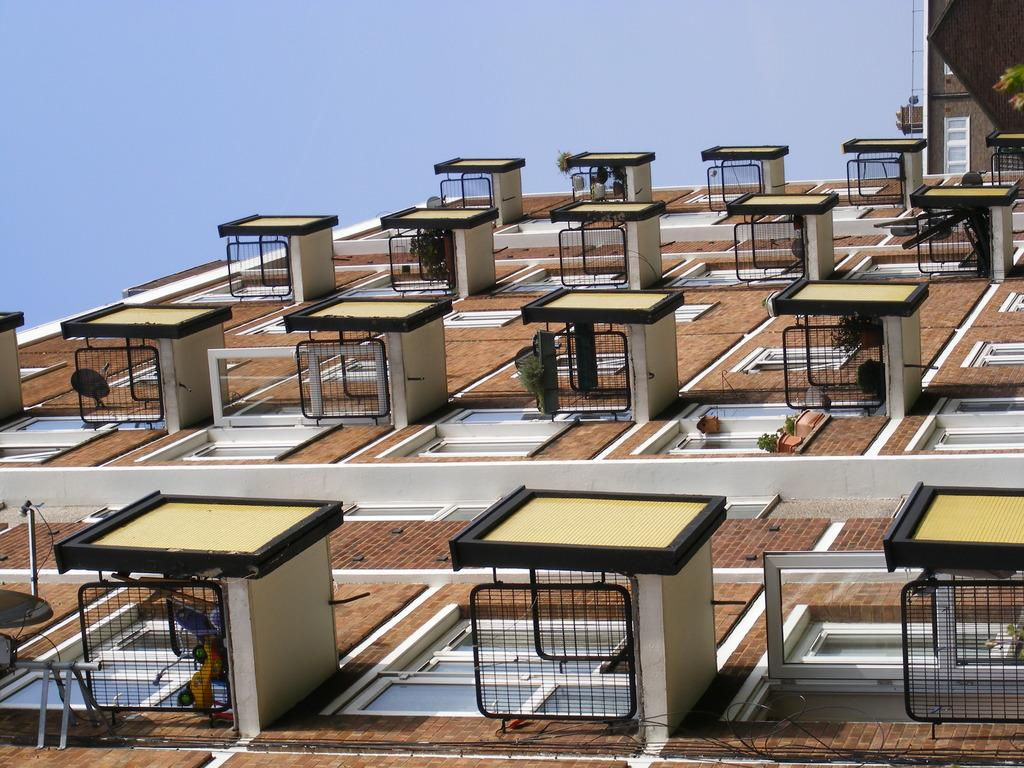What type of structures can be seen in the image? There are buildings in the image. What is the purpose of these buildings? The buildings belong to different departments. What type of screw can be seen on the coast in the image? There is no screw or coast present in the image; it only features buildings belonging to different departments. 